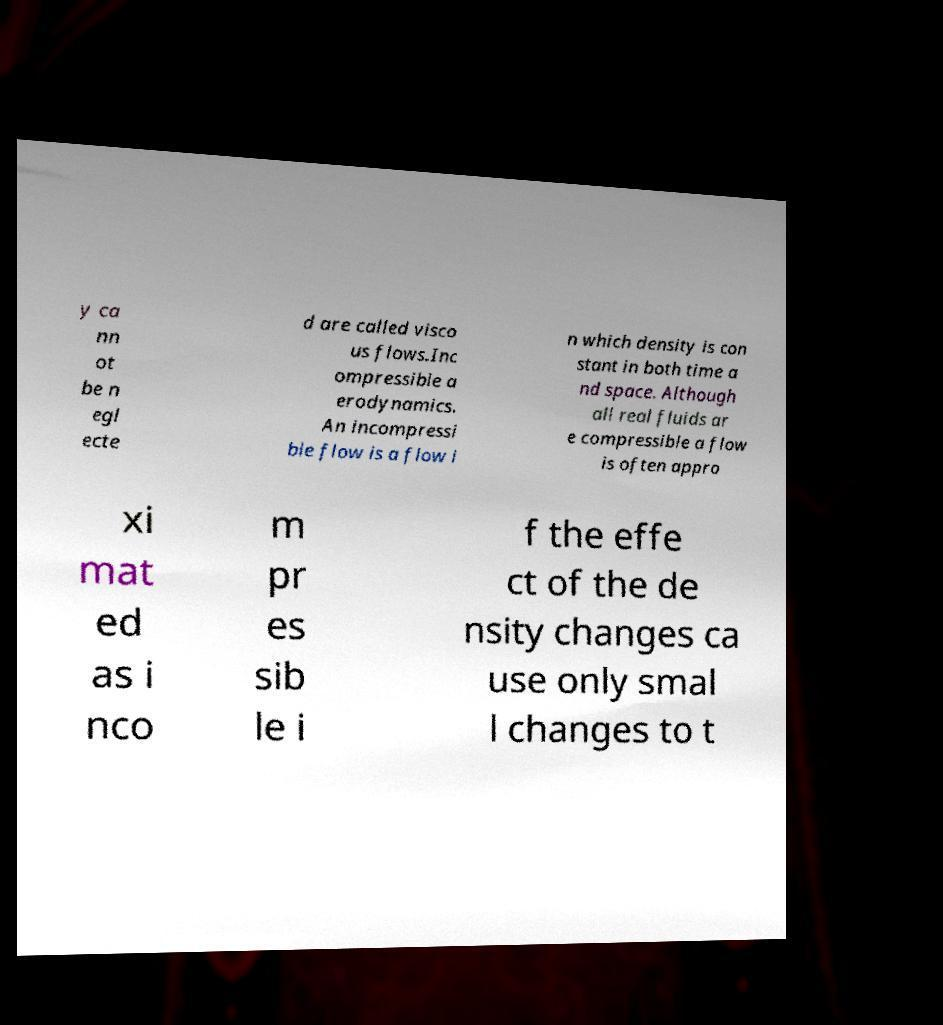There's text embedded in this image that I need extracted. Can you transcribe it verbatim? y ca nn ot be n egl ecte d are called visco us flows.Inc ompressible a erodynamics. An incompressi ble flow is a flow i n which density is con stant in both time a nd space. Although all real fluids ar e compressible a flow is often appro xi mat ed as i nco m pr es sib le i f the effe ct of the de nsity changes ca use only smal l changes to t 